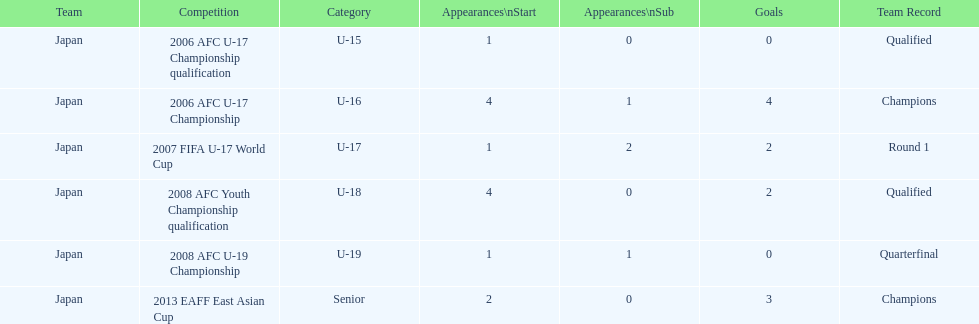In which two contests did japan experience a shortage of goals? 2006 AFC U-17 Championship qualification, 2008 AFC U-19 Championship. 